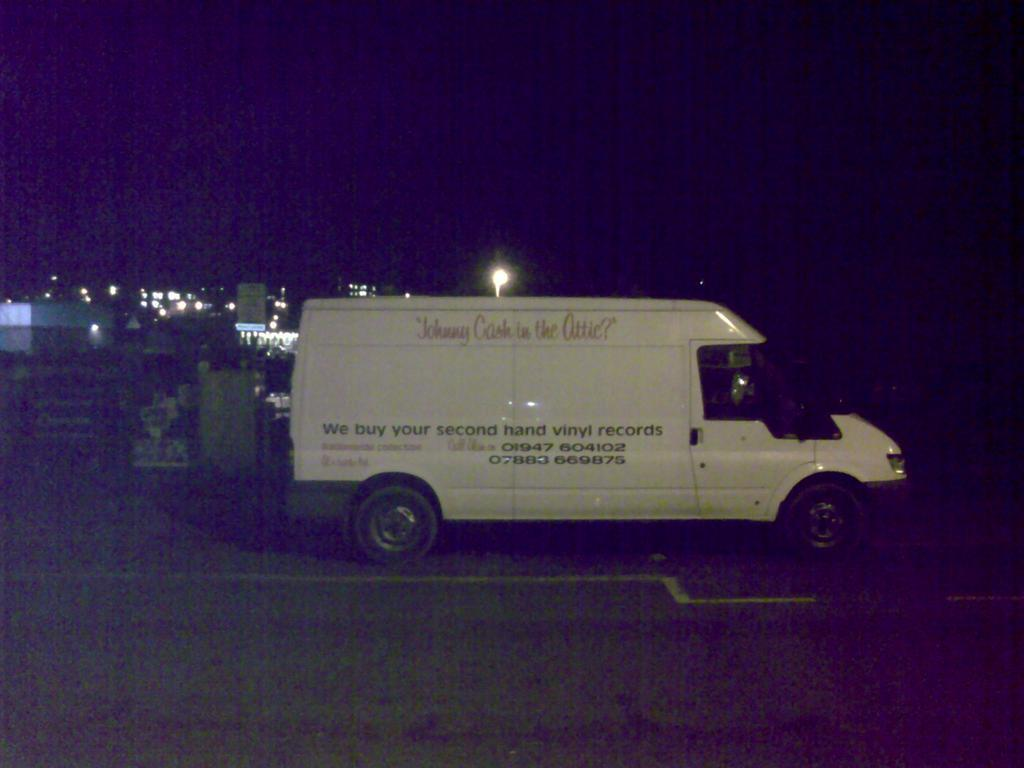What type of vehicle is in the image? There is a white color truck in the image. Where is the truck located in the image? The truck is in the front of the image. What can be seen in the background of the image? There are buildings and lights visible in the background of the image. What arithmetic problem is being solved on the side of the truck? There is no arithmetic problem visible on the side of the truck in the image. What type of sticks are being used to prop up the truck in the image? The truck does not require sticks for support, and there are no sticks visible in the image. 